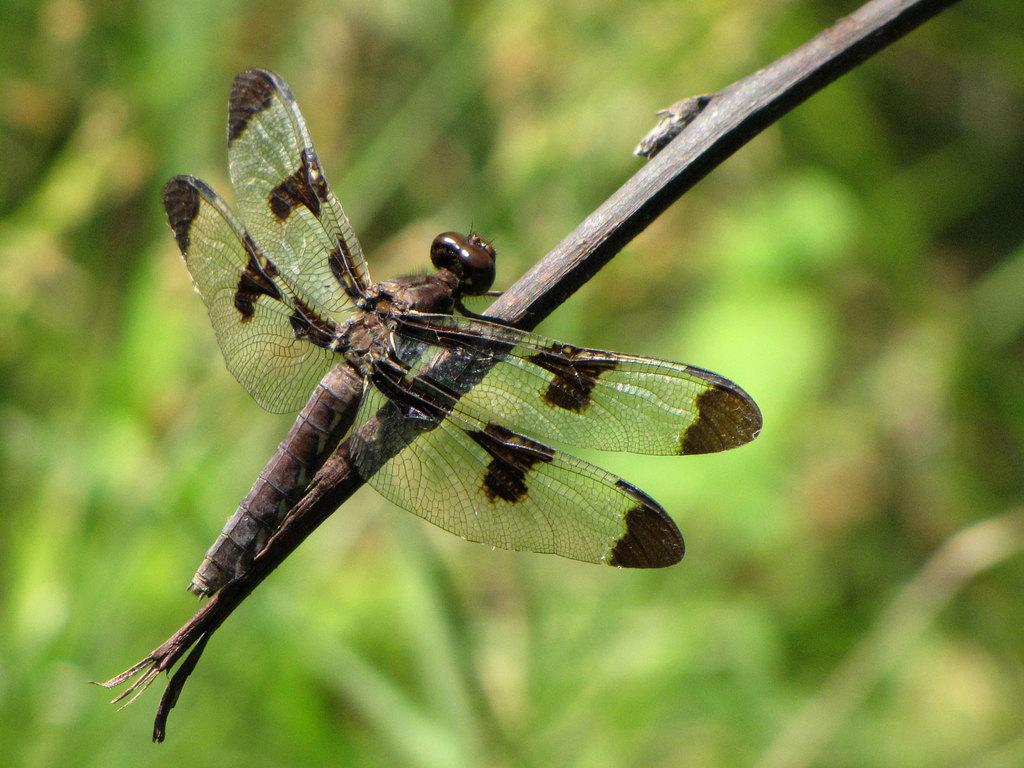What insect can be seen in the image? There is a dragonfly in the image. Where is the dragonfly located? The dragonfly is on a stem. What is the appearance of the background in the image? The background of the image is blurred. What type of environment is suggested by the background? There is greenery in the background of the image, suggesting a natural or outdoor setting. What type of pen is the dragonfly using to write in the image? There is no pen present in the image, and dragonflies do not have the ability to write. 